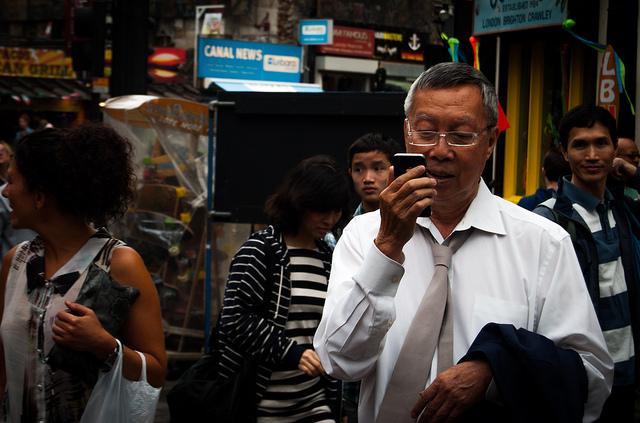What credit card company is advertised in the background?
Be succinct. Visa. What is the predominant gender of the people in the photo?
Give a very brief answer. Male. What animal print is on the  clutch purse that the woman is holding?
Quick response, please. Snake. Does the man in front have perfect vision?
Short answer required. No. 